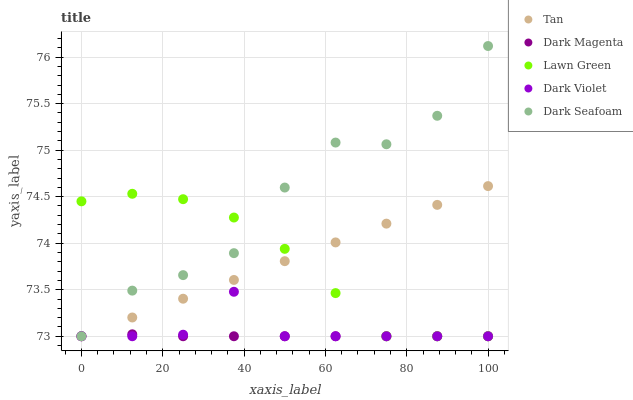Does Dark Magenta have the minimum area under the curve?
Answer yes or no. Yes. Does Dark Seafoam have the maximum area under the curve?
Answer yes or no. Yes. Does Lawn Green have the minimum area under the curve?
Answer yes or no. No. Does Lawn Green have the maximum area under the curve?
Answer yes or no. No. Is Tan the smoothest?
Answer yes or no. Yes. Is Dark Seafoam the roughest?
Answer yes or no. Yes. Is Lawn Green the smoothest?
Answer yes or no. No. Is Lawn Green the roughest?
Answer yes or no. No. Does Dark Seafoam have the lowest value?
Answer yes or no. Yes. Does Dark Seafoam have the highest value?
Answer yes or no. Yes. Does Lawn Green have the highest value?
Answer yes or no. No. Does Dark Magenta intersect Lawn Green?
Answer yes or no. Yes. Is Dark Magenta less than Lawn Green?
Answer yes or no. No. Is Dark Magenta greater than Lawn Green?
Answer yes or no. No. 